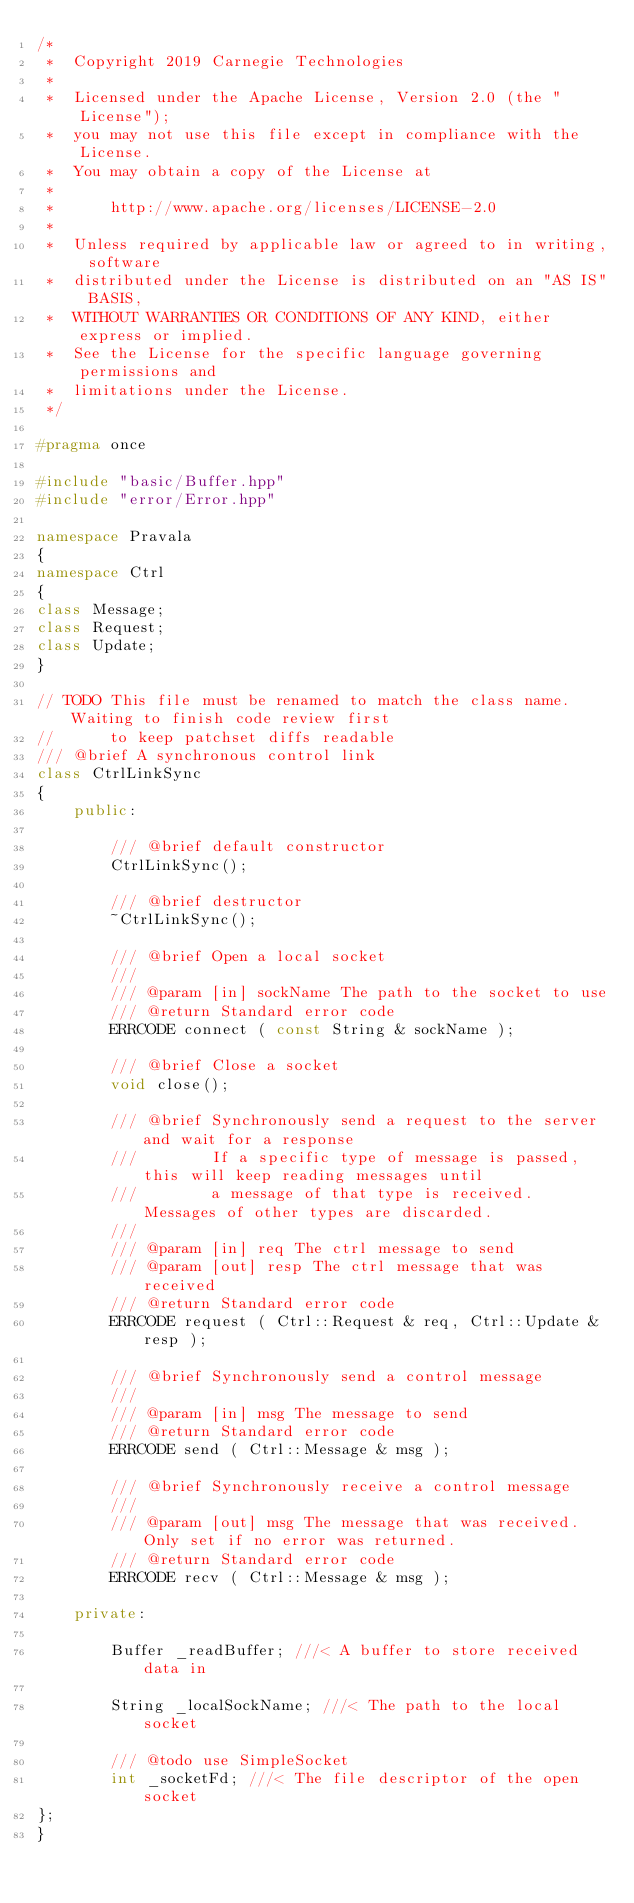<code> <loc_0><loc_0><loc_500><loc_500><_C++_>/*
 *  Copyright 2019 Carnegie Technologies
 *
 *  Licensed under the Apache License, Version 2.0 (the "License");
 *  you may not use this file except in compliance with the License.
 *  You may obtain a copy of the License at
 *
 *      http://www.apache.org/licenses/LICENSE-2.0
 *
 *  Unless required by applicable law or agreed to in writing, software
 *  distributed under the License is distributed on an "AS IS" BASIS,
 *  WITHOUT WARRANTIES OR CONDITIONS OF ANY KIND, either express or implied.
 *  See the License for the specific language governing permissions and
 *  limitations under the License.
 */

#pragma once

#include "basic/Buffer.hpp"
#include "error/Error.hpp"

namespace Pravala
{
namespace Ctrl
{
class Message;
class Request;
class Update;
}

// TODO This file must be renamed to match the class name. Waiting to finish code review first
//      to keep patchset diffs readable
/// @brief A synchronous control link
class CtrlLinkSync
{
    public:

        /// @brief default constructor
        CtrlLinkSync();

        /// @brief destructor
        ~CtrlLinkSync();

        /// @brief Open a local socket
        ///
        /// @param [in] sockName The path to the socket to use
        /// @return Standard error code
        ERRCODE connect ( const String & sockName );

        /// @brief Close a socket
        void close();

        /// @brief Synchronously send a request to the server and wait for a response
        ///        If a specific type of message is passed, this will keep reading messages until
        ///        a message of that type is received. Messages of other types are discarded.
        ///
        /// @param [in] req The ctrl message to send
        /// @param [out] resp The ctrl message that was received
        /// @return Standard error code
        ERRCODE request ( Ctrl::Request & req, Ctrl::Update & resp );

        /// @brief Synchronously send a control message
        ///
        /// @param [in] msg The message to send
        /// @return Standard error code
        ERRCODE send ( Ctrl::Message & msg );

        /// @brief Synchronously receive a control message
        ///
        /// @param [out] msg The message that was received. Only set if no error was returned.
        /// @return Standard error code
        ERRCODE recv ( Ctrl::Message & msg );

    private:

        Buffer _readBuffer; ///< A buffer to store received data in

        String _localSockName; ///< The path to the local socket

        /// @todo use SimpleSocket
        int _socketFd; ///< The file descriptor of the open socket
};
}
</code> 